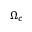Convert formula to latex. <formula><loc_0><loc_0><loc_500><loc_500>\Omega _ { c }</formula> 